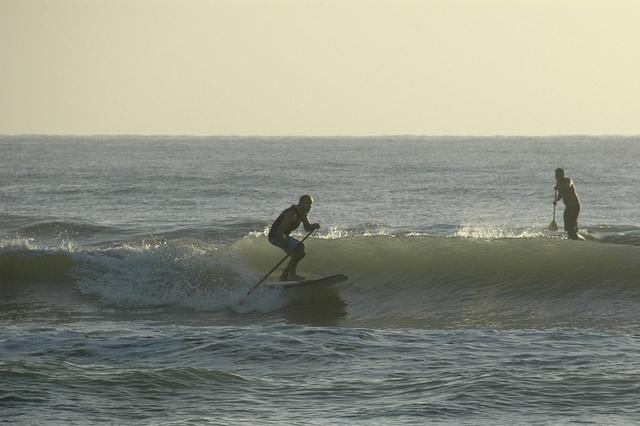What is the person standing on?
Give a very brief answer. Surfboard. Is he stand up paddle surfing?
Short answer required. Yes. Is this person standing on the surfboard?
Write a very short answer. Yes. Does this configuration seem synchronized, whether or not it is?
Concise answer only. No. What are the surfers wearing?
Answer briefly. Wetsuits. What color wave is this surfer riding on?
Write a very short answer. Green. How many people are in the water?
Answer briefly. 2. Approximately how tall is the ocean wave?
Give a very brief answer. 3 feet. How many people are in this photo?
Keep it brief. 2. 